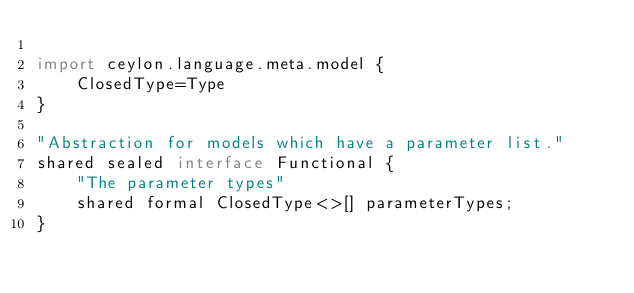<code> <loc_0><loc_0><loc_500><loc_500><_Ceylon_>
import ceylon.language.meta.model {
    ClosedType=Type
}

"Abstraction for models which have a parameter list."
shared sealed interface Functional {
    "The parameter types"
    shared formal ClosedType<>[] parameterTypes;
}

</code> 